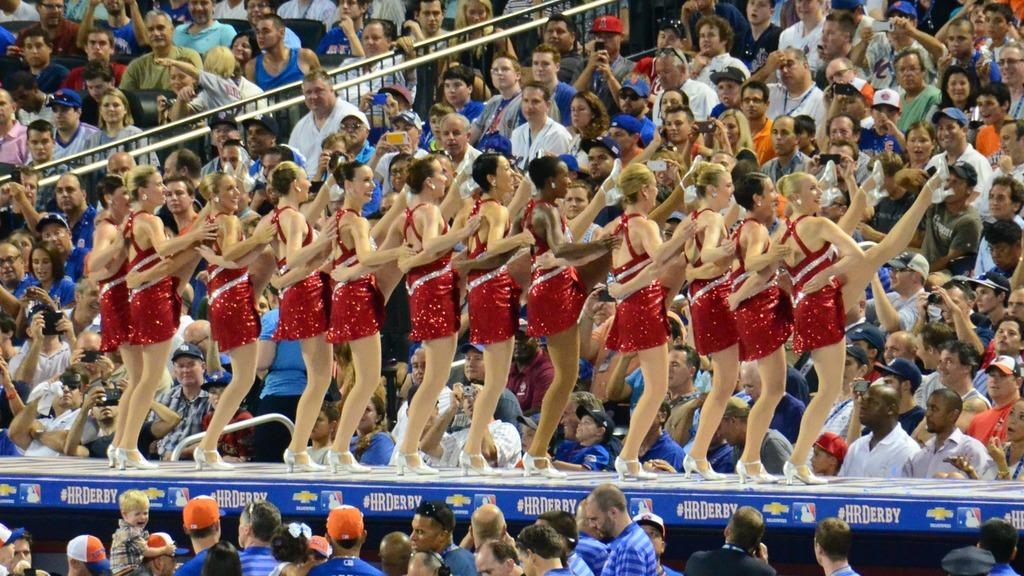What are the girls in the image doing? The girls in the image are dancing in the center. What can be seen in the background of the image? There is a crowd sitting in the background of the image. What type of zipper can be seen on the coat worn by the ant in the image? There is no ant or coat with a zipper present in the image. 